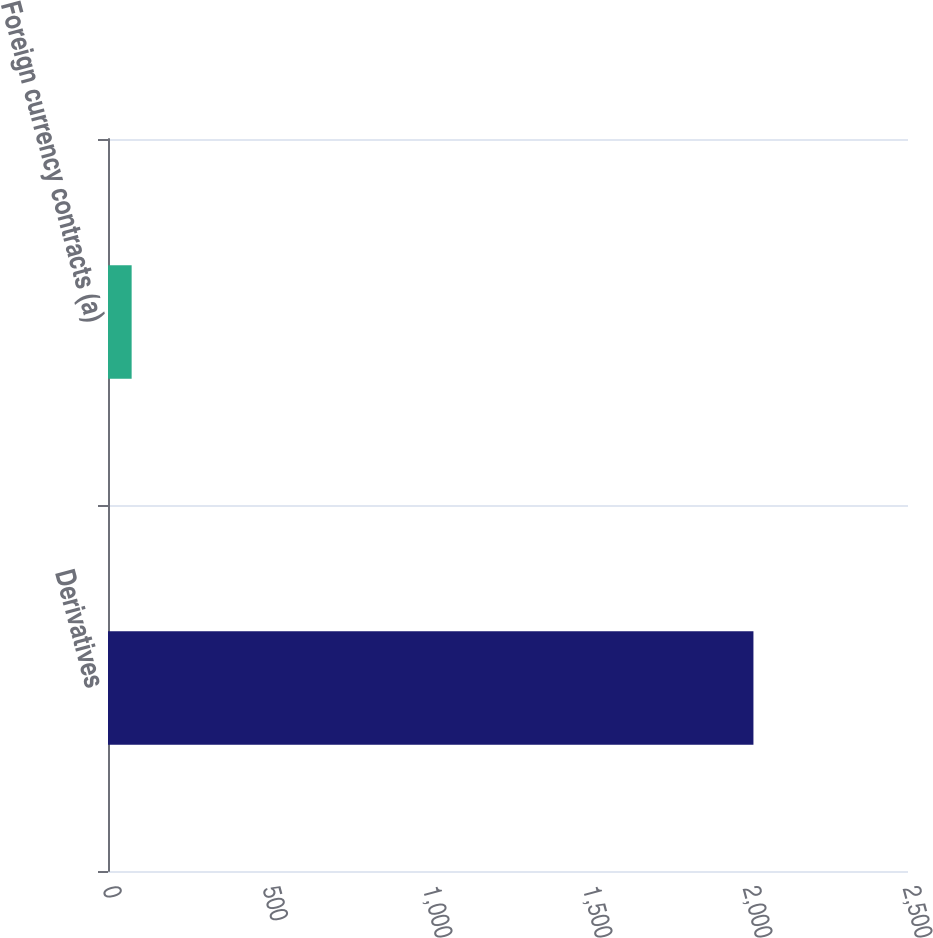Convert chart to OTSL. <chart><loc_0><loc_0><loc_500><loc_500><bar_chart><fcel>Derivatives<fcel>Foreign currency contracts (a)<nl><fcel>2017<fcel>73.9<nl></chart> 